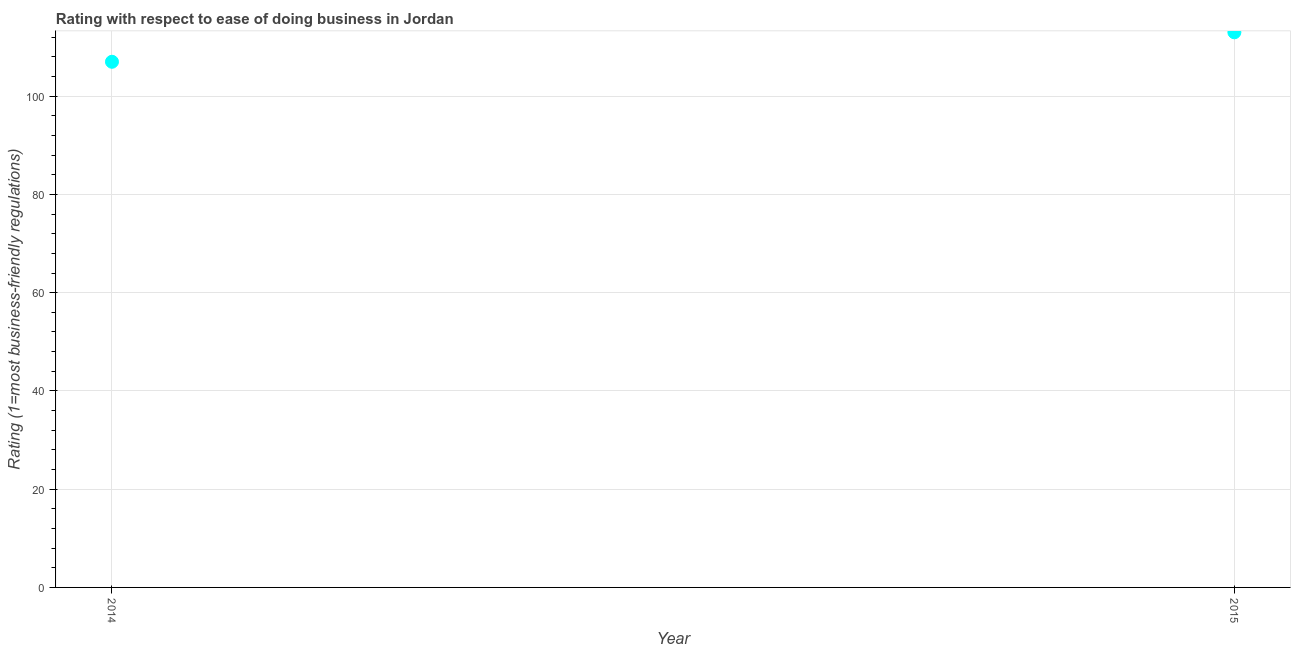What is the ease of doing business index in 2015?
Give a very brief answer. 113. Across all years, what is the maximum ease of doing business index?
Offer a terse response. 113. Across all years, what is the minimum ease of doing business index?
Offer a terse response. 107. In which year was the ease of doing business index maximum?
Your answer should be very brief. 2015. What is the sum of the ease of doing business index?
Make the answer very short. 220. What is the difference between the ease of doing business index in 2014 and 2015?
Your answer should be very brief. -6. What is the average ease of doing business index per year?
Your answer should be very brief. 110. What is the median ease of doing business index?
Offer a very short reply. 110. Do a majority of the years between 2015 and 2014 (inclusive) have ease of doing business index greater than 36 ?
Provide a short and direct response. No. What is the ratio of the ease of doing business index in 2014 to that in 2015?
Keep it short and to the point. 0.95. Does the ease of doing business index monotonically increase over the years?
Keep it short and to the point. Yes. Does the graph contain any zero values?
Provide a succinct answer. No. What is the title of the graph?
Your response must be concise. Rating with respect to ease of doing business in Jordan. What is the label or title of the Y-axis?
Your response must be concise. Rating (1=most business-friendly regulations). What is the Rating (1=most business-friendly regulations) in 2014?
Ensure brevity in your answer.  107. What is the Rating (1=most business-friendly regulations) in 2015?
Give a very brief answer. 113. What is the difference between the Rating (1=most business-friendly regulations) in 2014 and 2015?
Ensure brevity in your answer.  -6. What is the ratio of the Rating (1=most business-friendly regulations) in 2014 to that in 2015?
Your response must be concise. 0.95. 